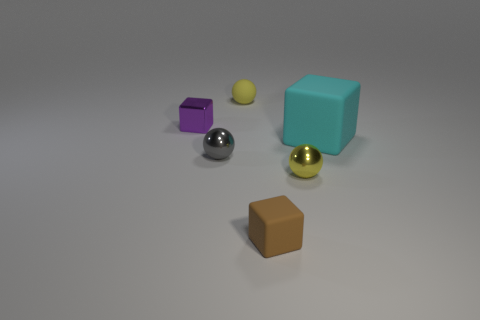There is a tiny metal thing that is the same color as the tiny rubber sphere; what is its shape?
Keep it short and to the point. Sphere. Are there any other yellow matte things of the same shape as the tiny yellow rubber object?
Make the answer very short. No. Are there the same number of cyan blocks that are in front of the large rubber object and purple blocks that are in front of the purple block?
Give a very brief answer. Yes. Are there any other things that have the same size as the brown block?
Your answer should be very brief. Yes. How many purple objects are either big cubes or small shiny spheres?
Your answer should be compact. 0. How many gray objects have the same size as the yellow metal thing?
Make the answer very short. 1. There is a block that is both left of the large cyan cube and behind the small brown object; what color is it?
Offer a very short reply. Purple. Are there more yellow metallic things that are on the left side of the small metallic cube than big blue metallic spheres?
Provide a short and direct response. No. Are any small gray cubes visible?
Your response must be concise. No. Do the tiny rubber cube and the large matte object have the same color?
Your response must be concise. No. 